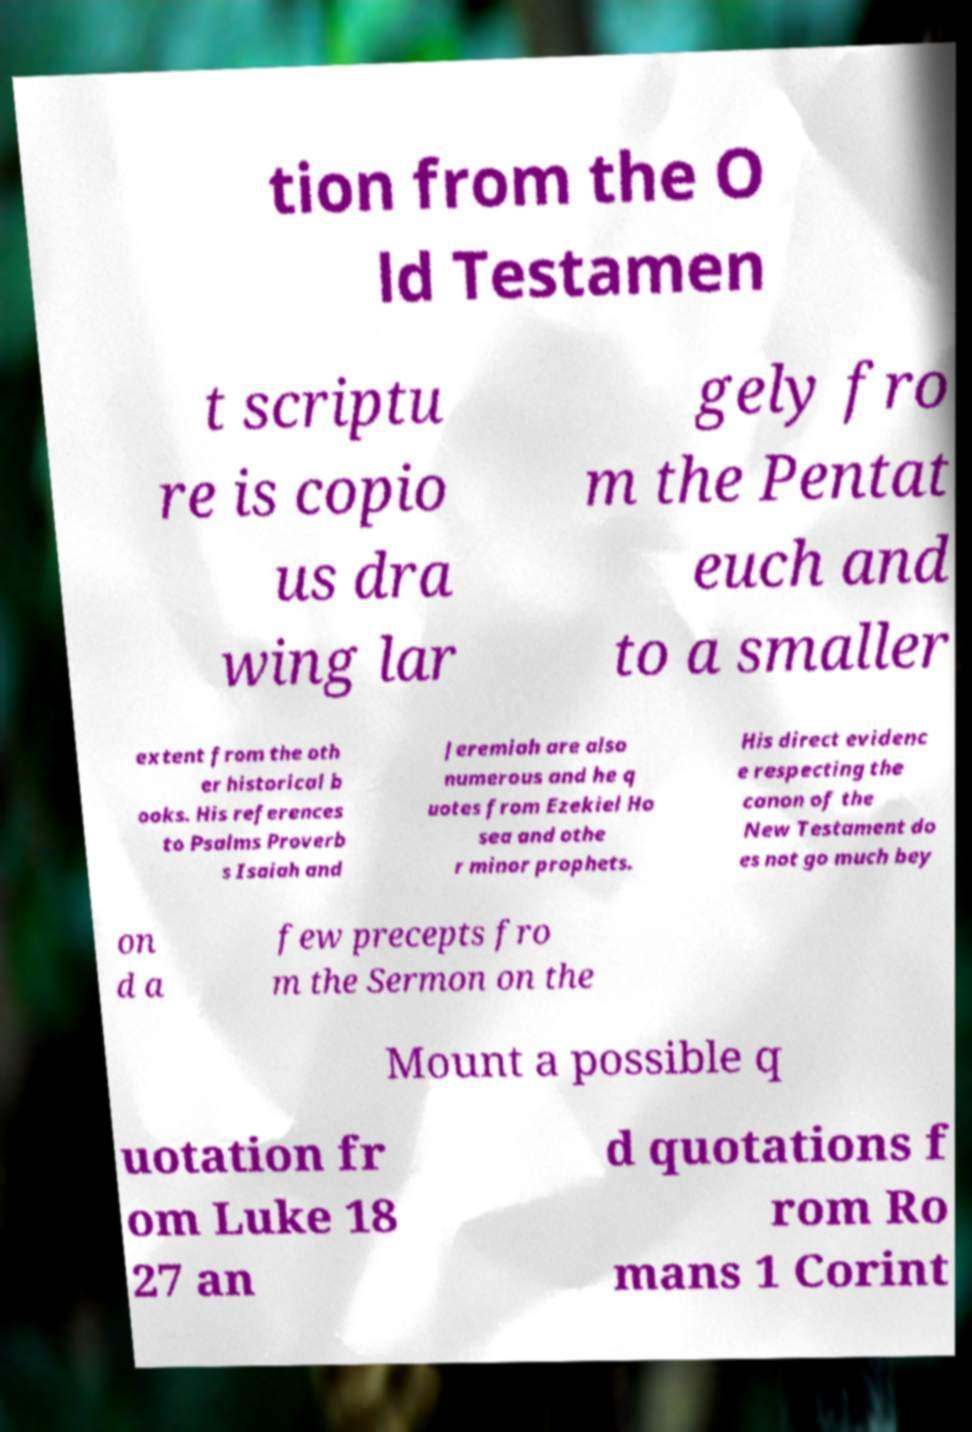Could you assist in decoding the text presented in this image and type it out clearly? tion from the O ld Testamen t scriptu re is copio us dra wing lar gely fro m the Pentat euch and to a smaller extent from the oth er historical b ooks. His references to Psalms Proverb s Isaiah and Jeremiah are also numerous and he q uotes from Ezekiel Ho sea and othe r minor prophets. His direct evidenc e respecting the canon of the New Testament do es not go much bey on d a few precepts fro m the Sermon on the Mount a possible q uotation fr om Luke 18 27 an d quotations f rom Ro mans 1 Corint 